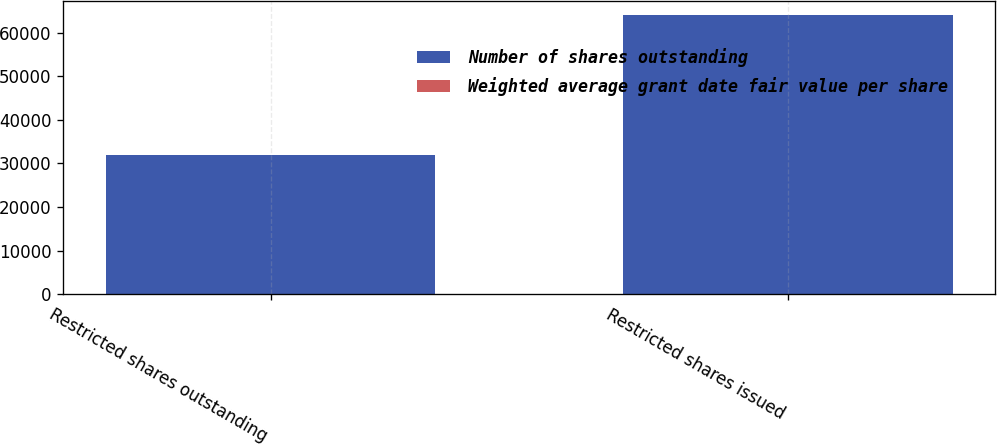Convert chart to OTSL. <chart><loc_0><loc_0><loc_500><loc_500><stacked_bar_chart><ecel><fcel>Restricted shares outstanding<fcel>Restricted shares issued<nl><fcel>Number of shares outstanding<fcel>32000<fcel>64000<nl><fcel>Weighted average grant date fair value per share<fcel>43.76<fcel>43.76<nl></chart> 